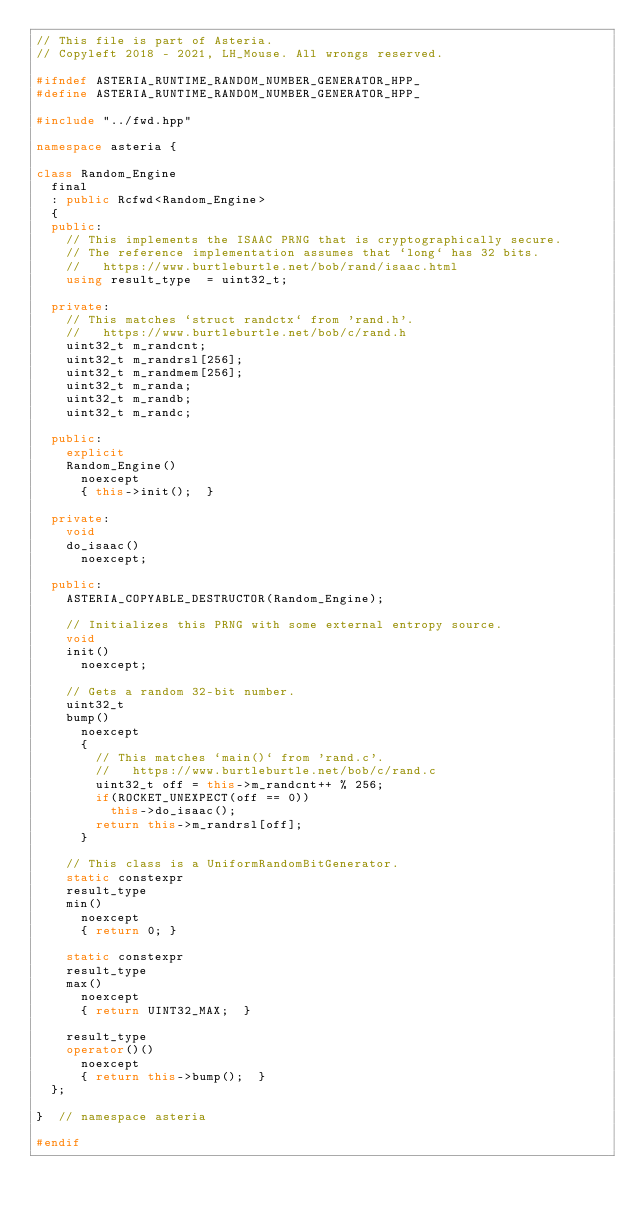Convert code to text. <code><loc_0><loc_0><loc_500><loc_500><_C++_>// This file is part of Asteria.
// Copyleft 2018 - 2021, LH_Mouse. All wrongs reserved.

#ifndef ASTERIA_RUNTIME_RANDOM_NUMBER_GENERATOR_HPP_
#define ASTERIA_RUNTIME_RANDOM_NUMBER_GENERATOR_HPP_

#include "../fwd.hpp"

namespace asteria {

class Random_Engine
  final
  : public Rcfwd<Random_Engine>
  {
  public:
    // This implements the ISAAC PRNG that is cryptographically secure.
    // The reference implementation assumes that `long` has 32 bits.
    //   https://www.burtleburtle.net/bob/rand/isaac.html
    using result_type  = uint32_t;

  private:
    // This matches `struct randctx` from 'rand.h'.
    //   https://www.burtleburtle.net/bob/c/rand.h
    uint32_t m_randcnt;
    uint32_t m_randrsl[256];
    uint32_t m_randmem[256];
    uint32_t m_randa;
    uint32_t m_randb;
    uint32_t m_randc;

  public:
    explicit
    Random_Engine()
      noexcept
      { this->init();  }

  private:
    void
    do_isaac()
      noexcept;

  public:
    ASTERIA_COPYABLE_DESTRUCTOR(Random_Engine);

    // Initializes this PRNG with some external entropy source.
    void
    init()
      noexcept;

    // Gets a random 32-bit number.
    uint32_t
    bump()
      noexcept
      {
        // This matches `main()` from 'rand.c'.
        //   https://www.burtleburtle.net/bob/c/rand.c
        uint32_t off = this->m_randcnt++ % 256;
        if(ROCKET_UNEXPECT(off == 0))
          this->do_isaac();
        return this->m_randrsl[off];
      }

    // This class is a UniformRandomBitGenerator.
    static constexpr
    result_type
    min()
      noexcept
      { return 0; }

    static constexpr
    result_type
    max()
      noexcept
      { return UINT32_MAX;  }

    result_type
    operator()()
      noexcept
      { return this->bump();  }
  };

}  // namespace asteria

#endif
</code> 